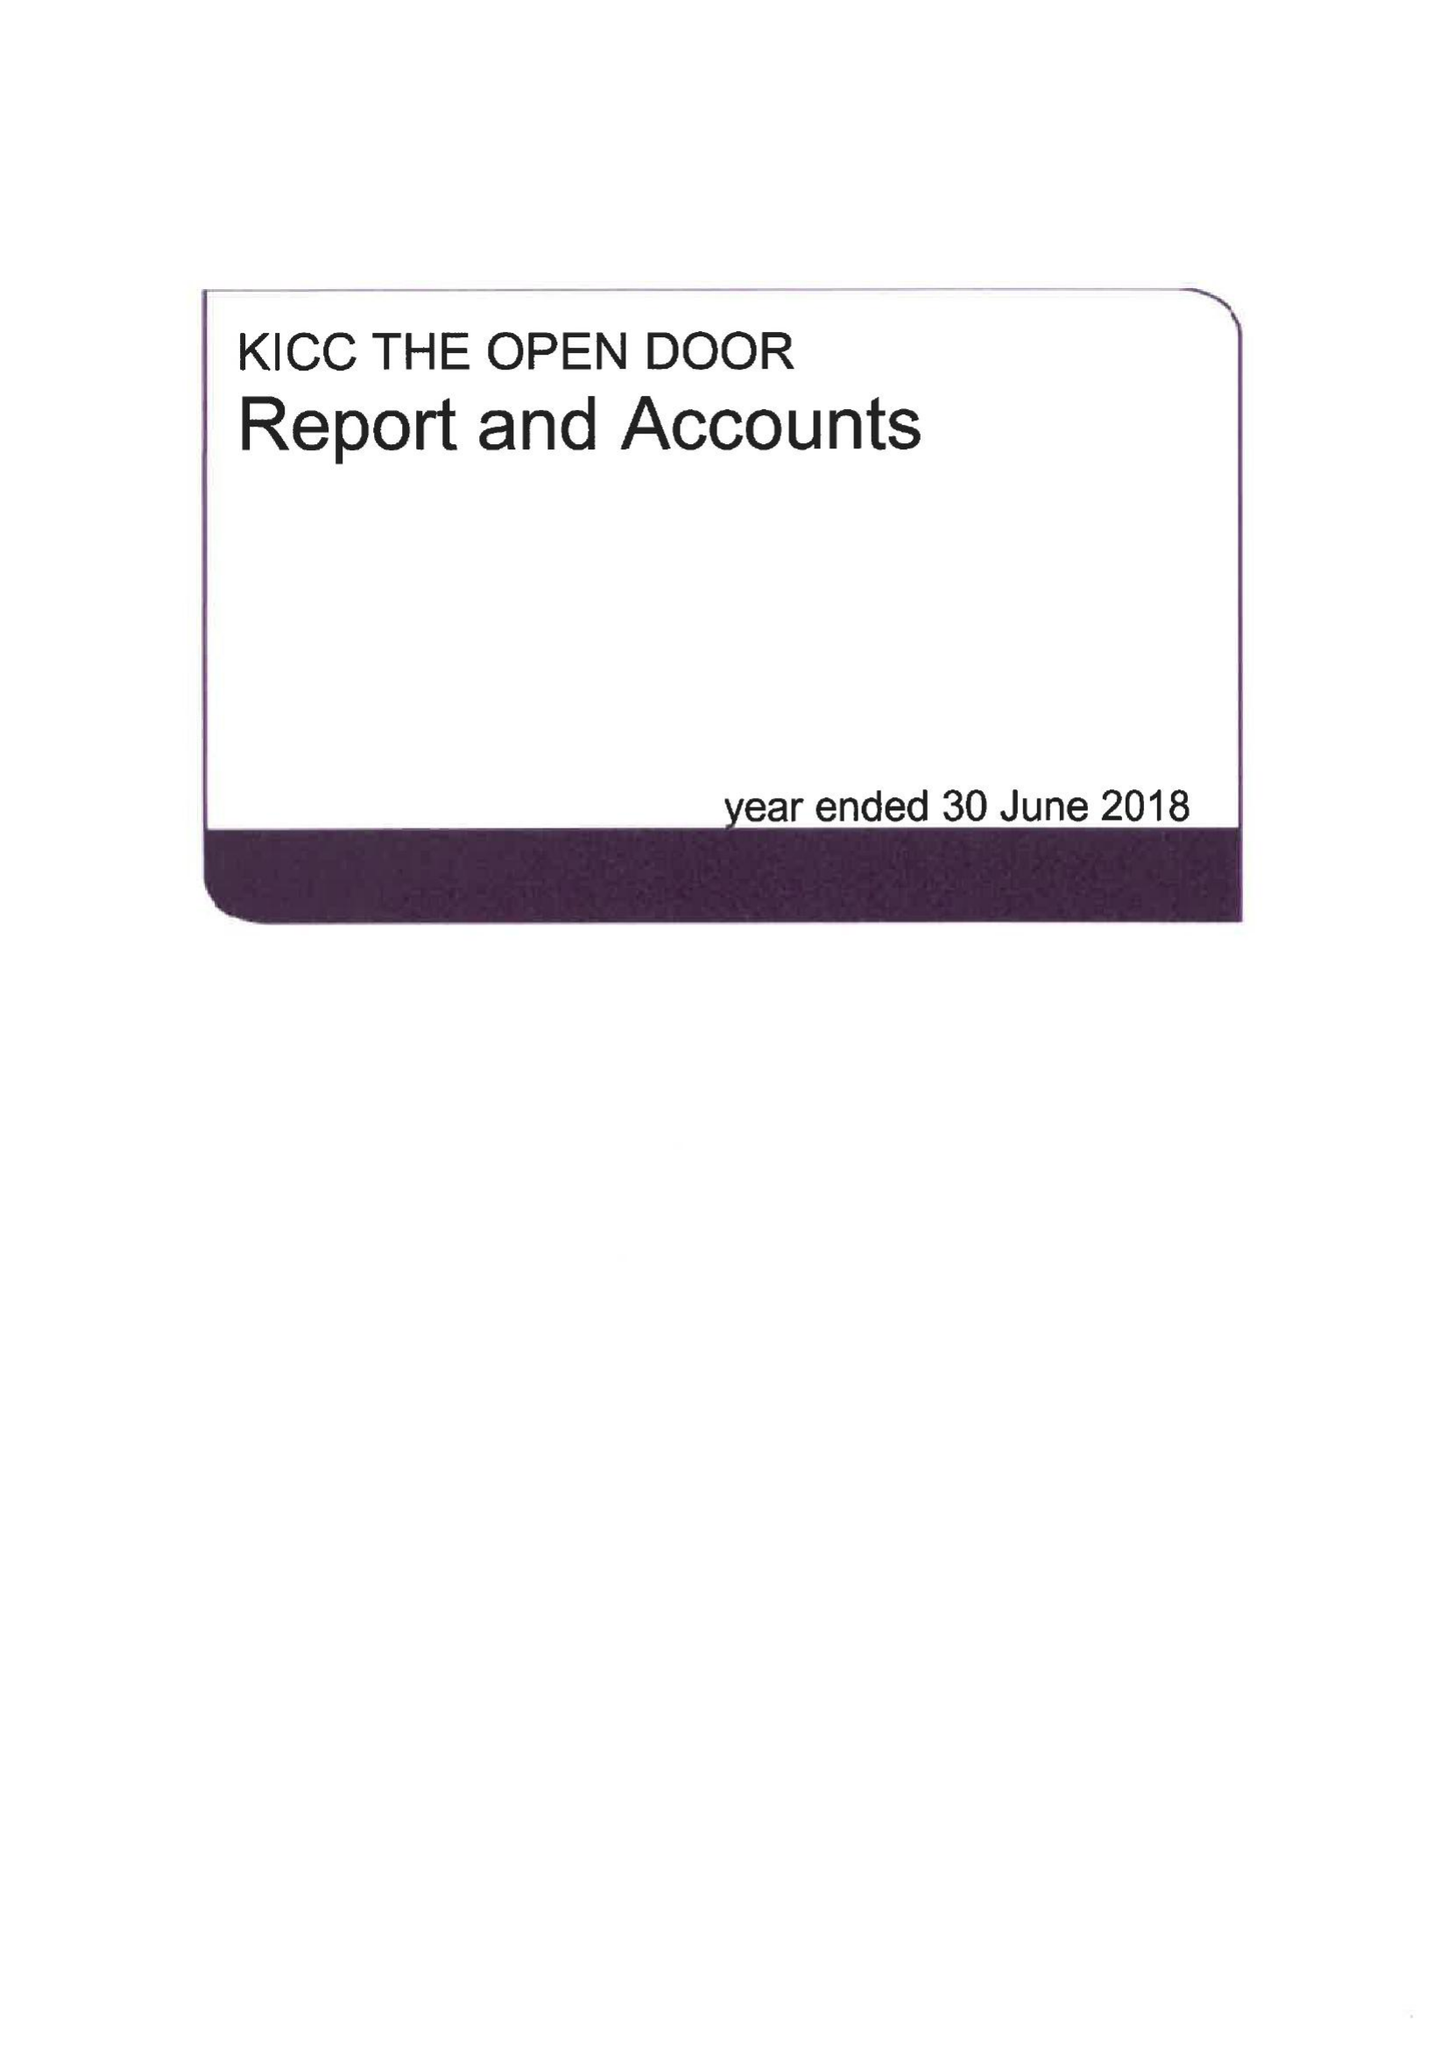What is the value for the address__street_line?
Answer the question using a single word or phrase. LOMBARD ROAD 